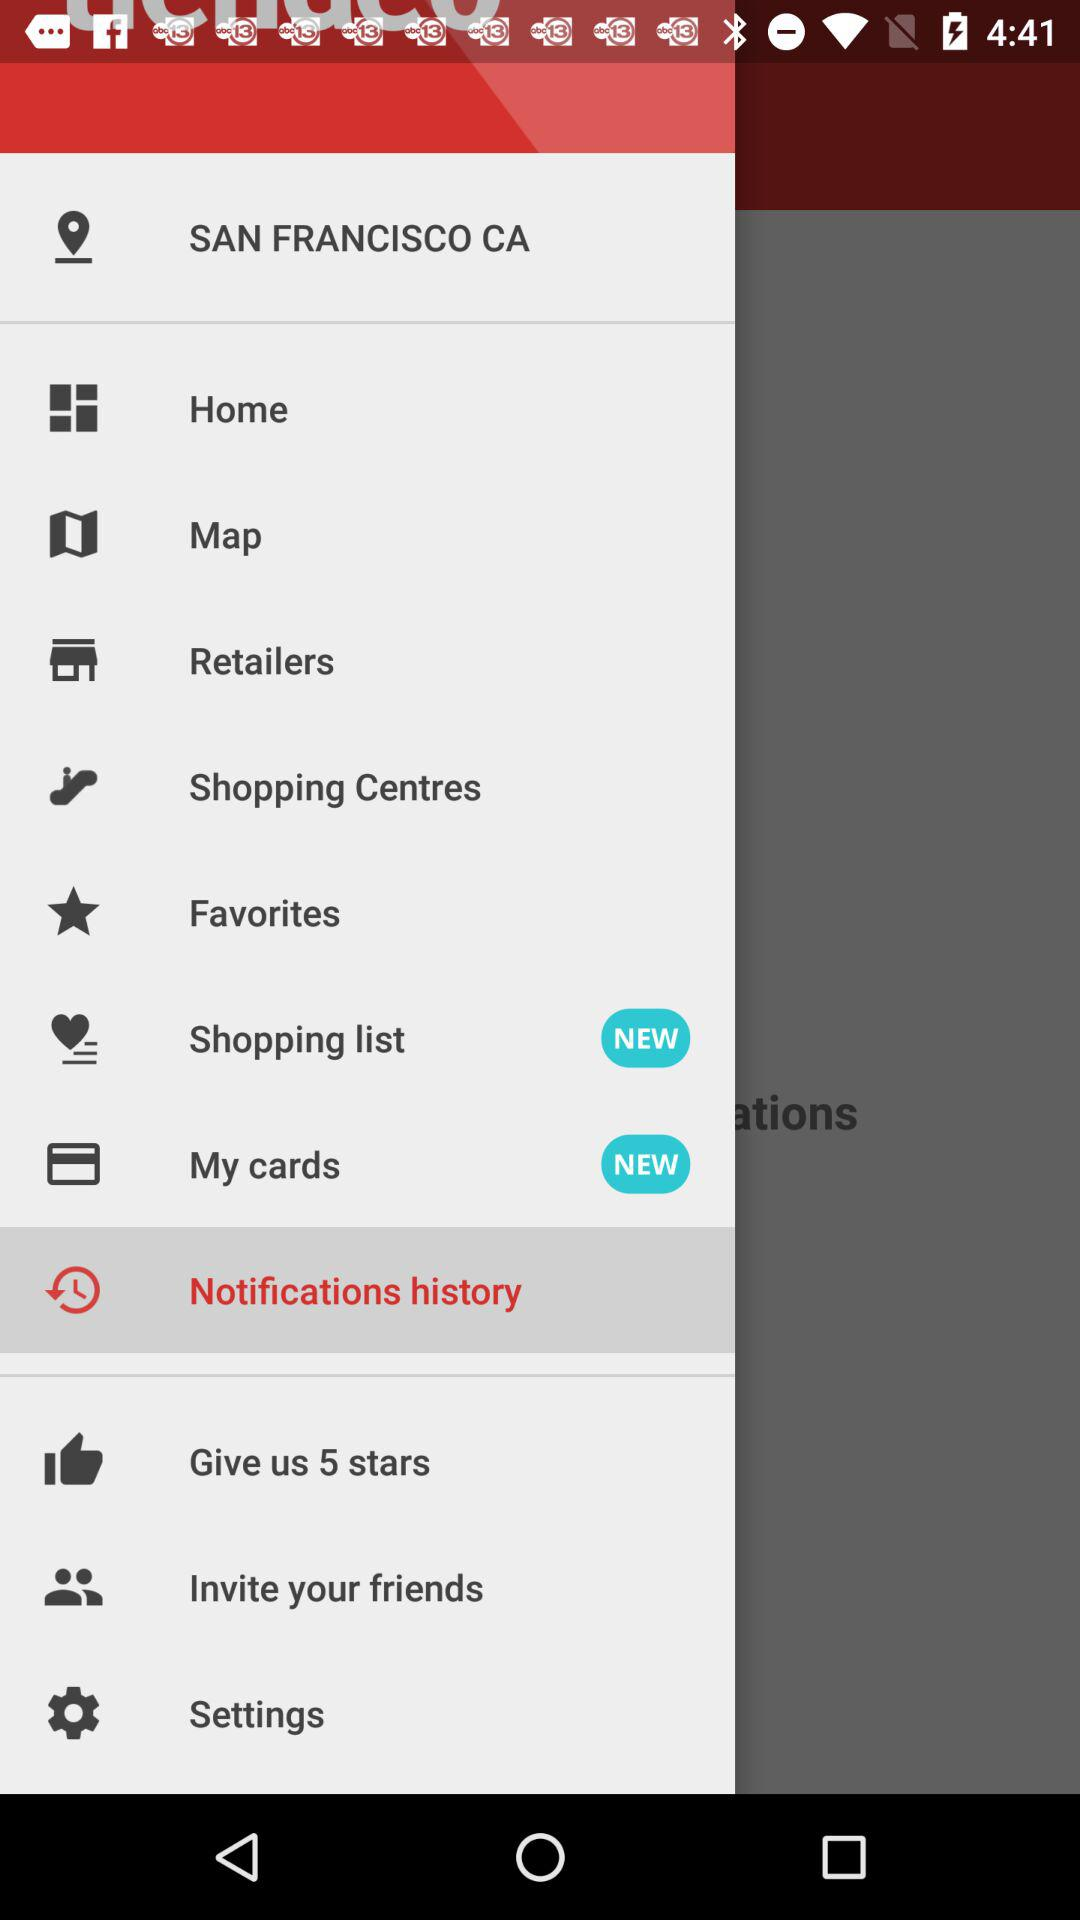Which item has been selected? The item "Notifications history" has been selected. 